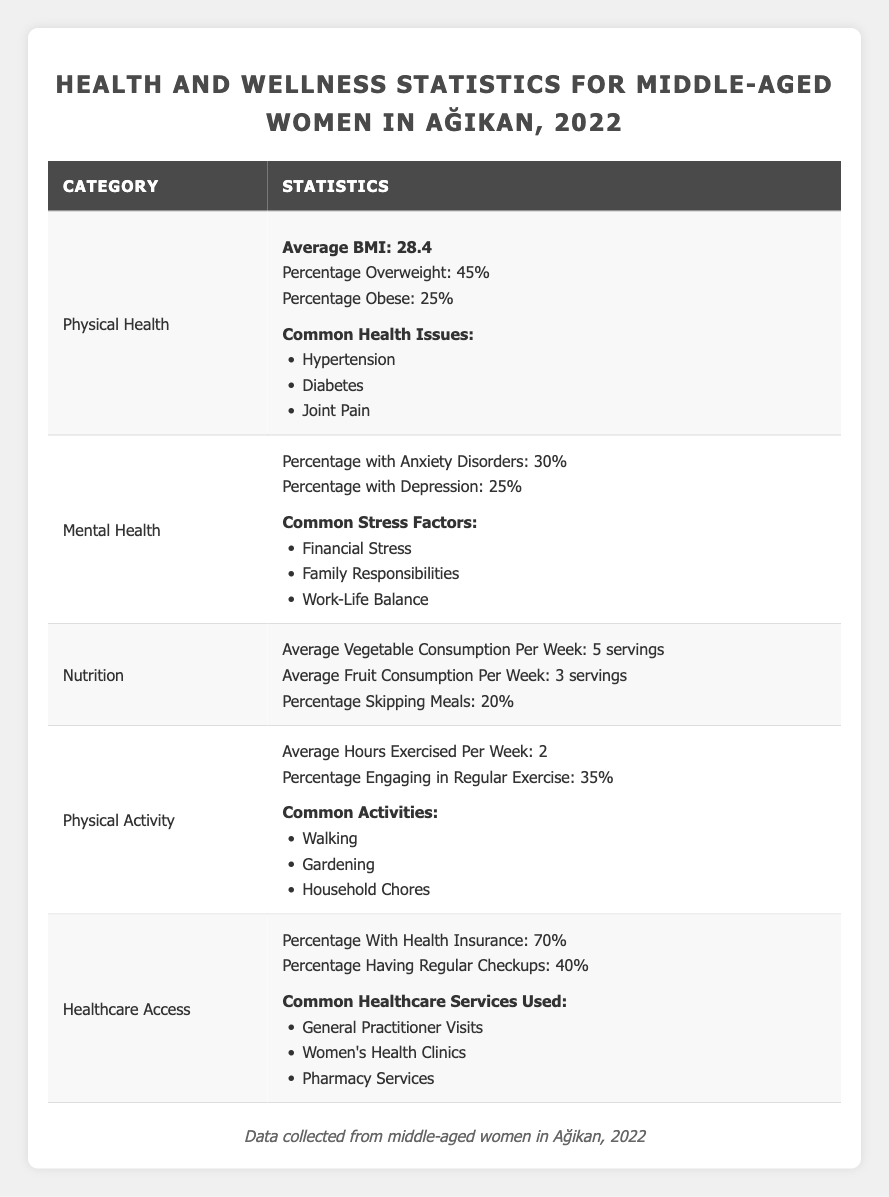What is the average BMI among middle-aged women in Ağikan for 2022? According to the table, the average BMI is listed directly under the Physical Health category. It states that the average BMI is 28.4.
Answer: 28.4 What percentage of middle-aged women in Ağikan are considered obese? The table shows that 25% of middle-aged women are classified as obese, which is provided in the Physical Health section.
Answer: 25% How many hours on average do middle-aged women in Ağikan exercise per week? The table indicates that the average hours exercised per week is stated under Physical Activity and that it reaches 2 hours.
Answer: 2 What is the percentage of middle-aged women who engage in regular exercise? The table reveals that 35% of middle-aged women engage in regular exercise, which is specifically noted in the Physical Activity section.
Answer: 35% What percentage of middle-aged women in Ağikan have health insurance? The Healthcare Access section of the table shows that 70% of middle-aged women have health insurance.
Answer: 70% What are the common health issues faced by middle-aged women in Ağikan? The common health issues are listed under the Physical Health category. These include Hypertension, Diabetes, and Joint Pain.
Answer: Hypertension, Diabetes, Joint Pain What is the total percentage of women in Ağikan experiencing anxiety or depression? To find this, you add the percentage of anxiety disorders (30%) and depression (25%). Therefore, 30 + 25 = 55%.
Answer: 55% How many servings of fruits do middle-aged women in Ağikan consume on average per week? The Nutrition section specifies that the average fruit consumption is 3 servings per week, directly answering the question.
Answer: 3 Is it true that a higher percentage of women skip meals than engage in regular exercise? From the table, 20% of women skip meals, which is lower than the 35% who engage in regular exercise. Therefore, the statement is false.
Answer: No What are the common stress factors reported among middle-aged women in Ağikan? The common stress factors are listed under the Mental Health section and they include Financial Stress, Family Responsibilities, and Work-Life Balance.
Answer: Financial Stress, Family Responsibilities, Work-Life Balance If 40% of women have regular checkups, what percentage do not have regular checkups? To find this, subtract the percentage of those with regular checkups (40%) from 100%. So, 100 - 40 = 60%.
Answer: 60 